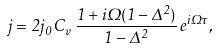<formula> <loc_0><loc_0><loc_500><loc_500>j = 2 j _ { 0 } \, C _ { v } \, \frac { 1 + i \Omega ( 1 - \Delta ^ { 2 } ) } { 1 - \Delta ^ { 2 } } \, e ^ { i \Omega \tau } ,</formula> 